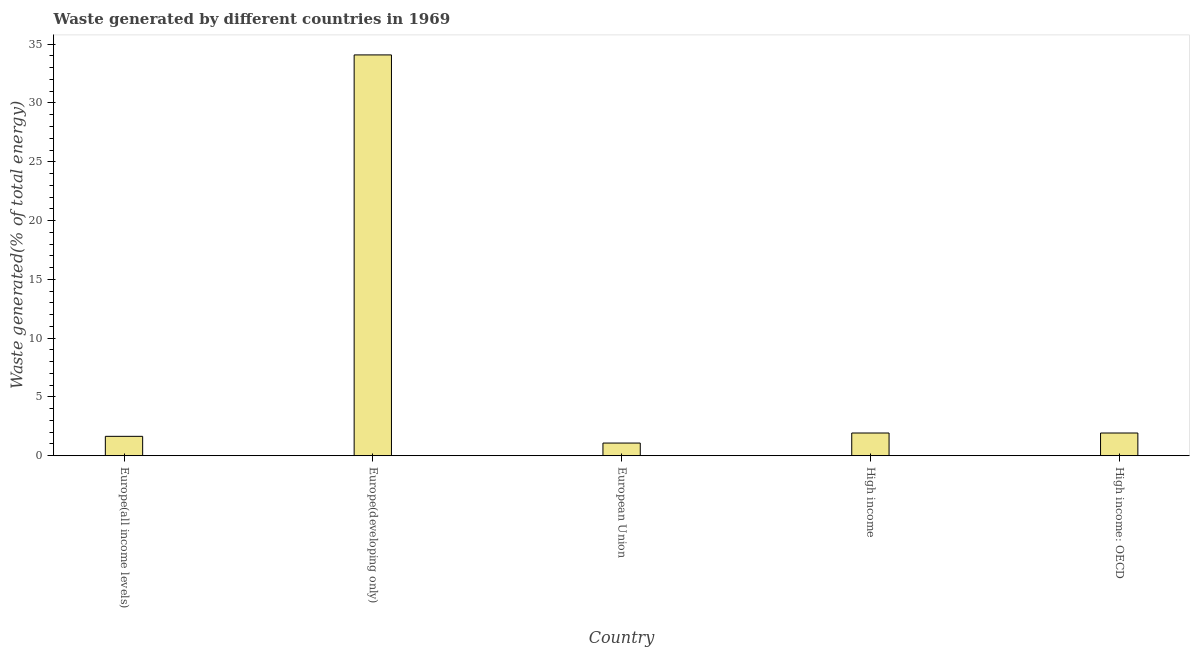Does the graph contain any zero values?
Make the answer very short. No. Does the graph contain grids?
Provide a succinct answer. No. What is the title of the graph?
Make the answer very short. Waste generated by different countries in 1969. What is the label or title of the X-axis?
Your answer should be compact. Country. What is the label or title of the Y-axis?
Give a very brief answer. Waste generated(% of total energy). What is the amount of waste generated in High income?
Your answer should be compact. 1.93. Across all countries, what is the maximum amount of waste generated?
Keep it short and to the point. 34.09. Across all countries, what is the minimum amount of waste generated?
Keep it short and to the point. 1.08. In which country was the amount of waste generated maximum?
Your answer should be very brief. Europe(developing only). What is the sum of the amount of waste generated?
Give a very brief answer. 40.68. What is the difference between the amount of waste generated in Europe(all income levels) and European Union?
Offer a terse response. 0.57. What is the average amount of waste generated per country?
Your response must be concise. 8.14. What is the median amount of waste generated?
Keep it short and to the point. 1.93. What is the ratio of the amount of waste generated in Europe(all income levels) to that in High income?
Provide a short and direct response. 0.85. Is the amount of waste generated in Europe(all income levels) less than that in European Union?
Ensure brevity in your answer.  No. Is the difference between the amount of waste generated in High income and High income: OECD greater than the difference between any two countries?
Make the answer very short. No. What is the difference between the highest and the second highest amount of waste generated?
Keep it short and to the point. 32.16. Is the sum of the amount of waste generated in High income and High income: OECD greater than the maximum amount of waste generated across all countries?
Your answer should be very brief. No. What is the difference between the highest and the lowest amount of waste generated?
Give a very brief answer. 33.01. In how many countries, is the amount of waste generated greater than the average amount of waste generated taken over all countries?
Offer a terse response. 1. How many countries are there in the graph?
Provide a succinct answer. 5. What is the difference between two consecutive major ticks on the Y-axis?
Keep it short and to the point. 5. What is the Waste generated(% of total energy) of Europe(all income levels)?
Keep it short and to the point. 1.65. What is the Waste generated(% of total energy) in Europe(developing only)?
Offer a very short reply. 34.09. What is the Waste generated(% of total energy) in European Union?
Keep it short and to the point. 1.08. What is the Waste generated(% of total energy) in High income?
Offer a very short reply. 1.93. What is the Waste generated(% of total energy) of High income: OECD?
Offer a terse response. 1.93. What is the difference between the Waste generated(% of total energy) in Europe(all income levels) and Europe(developing only)?
Give a very brief answer. -32.44. What is the difference between the Waste generated(% of total energy) in Europe(all income levels) and European Union?
Give a very brief answer. 0.57. What is the difference between the Waste generated(% of total energy) in Europe(all income levels) and High income?
Keep it short and to the point. -0.28. What is the difference between the Waste generated(% of total energy) in Europe(all income levels) and High income: OECD?
Provide a short and direct response. -0.28. What is the difference between the Waste generated(% of total energy) in Europe(developing only) and European Union?
Provide a short and direct response. 33.01. What is the difference between the Waste generated(% of total energy) in Europe(developing only) and High income?
Provide a short and direct response. 32.16. What is the difference between the Waste generated(% of total energy) in Europe(developing only) and High income: OECD?
Give a very brief answer. 32.16. What is the difference between the Waste generated(% of total energy) in European Union and High income?
Your answer should be very brief. -0.85. What is the difference between the Waste generated(% of total energy) in European Union and High income: OECD?
Give a very brief answer. -0.85. What is the difference between the Waste generated(% of total energy) in High income and High income: OECD?
Offer a terse response. 0. What is the ratio of the Waste generated(% of total energy) in Europe(all income levels) to that in Europe(developing only)?
Your answer should be compact. 0.05. What is the ratio of the Waste generated(% of total energy) in Europe(all income levels) to that in European Union?
Your response must be concise. 1.53. What is the ratio of the Waste generated(% of total energy) in Europe(all income levels) to that in High income?
Offer a very short reply. 0.85. What is the ratio of the Waste generated(% of total energy) in Europe(all income levels) to that in High income: OECD?
Make the answer very short. 0.85. What is the ratio of the Waste generated(% of total energy) in Europe(developing only) to that in European Union?
Provide a succinct answer. 31.62. What is the ratio of the Waste generated(% of total energy) in Europe(developing only) to that in High income?
Your answer should be very brief. 17.65. What is the ratio of the Waste generated(% of total energy) in Europe(developing only) to that in High income: OECD?
Your answer should be compact. 17.65. What is the ratio of the Waste generated(% of total energy) in European Union to that in High income?
Provide a short and direct response. 0.56. What is the ratio of the Waste generated(% of total energy) in European Union to that in High income: OECD?
Your answer should be compact. 0.56. What is the ratio of the Waste generated(% of total energy) in High income to that in High income: OECD?
Provide a short and direct response. 1. 